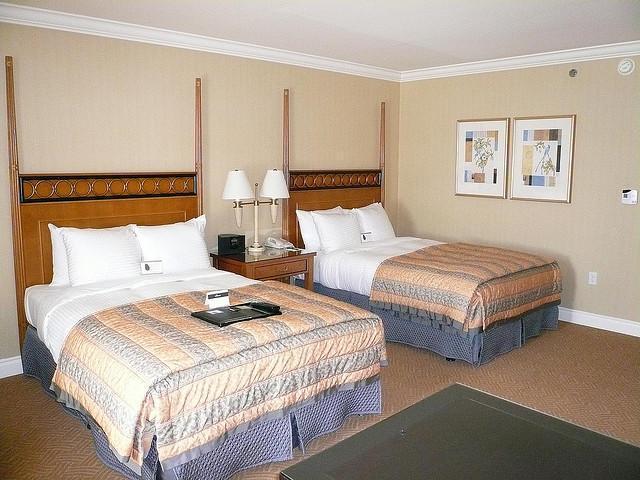How many beds are there?
Give a very brief answer. 2. How many lights are turned on?
Give a very brief answer. 0. How many people are wearing shorts in the forefront of this photo?
Give a very brief answer. 0. 